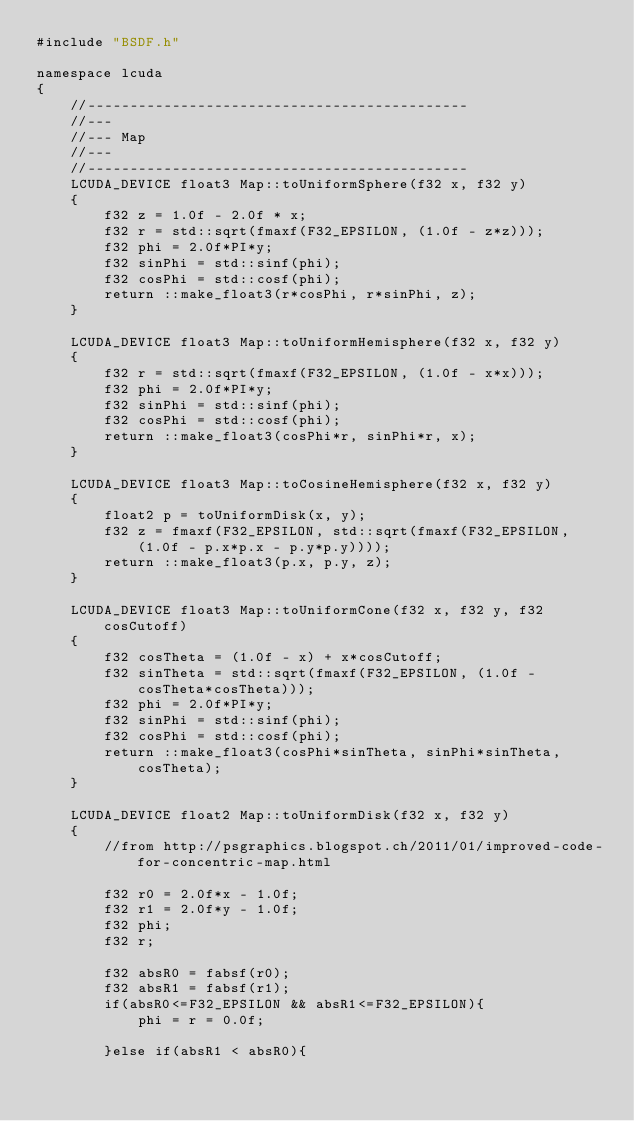Convert code to text. <code><loc_0><loc_0><loc_500><loc_500><_Cuda_>#include "BSDF.h"

namespace lcuda
{
    //---------------------------------------------
    //---
    //--- Map
    //---
    //---------------------------------------------
    LCUDA_DEVICE float3 Map::toUniformSphere(f32 x, f32 y)
    {
        f32 z = 1.0f - 2.0f * x;
        f32 r = std::sqrt(fmaxf(F32_EPSILON, (1.0f - z*z)));
        f32 phi = 2.0f*PI*y;
        f32 sinPhi = std::sinf(phi);
        f32 cosPhi = std::cosf(phi);
        return ::make_float3(r*cosPhi, r*sinPhi, z);
    }

    LCUDA_DEVICE float3 Map::toUniformHemisphere(f32 x, f32 y)
    {
        f32 r = std::sqrt(fmaxf(F32_EPSILON, (1.0f - x*x)));
        f32 phi = 2.0f*PI*y;
        f32 sinPhi = std::sinf(phi);
        f32 cosPhi = std::cosf(phi);
        return ::make_float3(cosPhi*r, sinPhi*r, x);
    }

    LCUDA_DEVICE float3 Map::toCosineHemisphere(f32 x, f32 y)
    {
        float2 p = toUniformDisk(x, y);
        f32 z = fmaxf(F32_EPSILON, std::sqrt(fmaxf(F32_EPSILON, (1.0f - p.x*p.x - p.y*p.y))));
        return ::make_float3(p.x, p.y, z);
    }

    LCUDA_DEVICE float3 Map::toUniformCone(f32 x, f32 y, f32 cosCutoff)
    {
        f32 cosTheta = (1.0f - x) + x*cosCutoff;
        f32 sinTheta = std::sqrt(fmaxf(F32_EPSILON, (1.0f - cosTheta*cosTheta)));
        f32 phi = 2.0f*PI*y;
        f32 sinPhi = std::sinf(phi);
        f32 cosPhi = std::cosf(phi);
        return ::make_float3(cosPhi*sinTheta, sinPhi*sinTheta, cosTheta);
    }

    LCUDA_DEVICE float2 Map::toUniformDisk(f32 x, f32 y)
    {
        //from http://psgraphics.blogspot.ch/2011/01/improved-code-for-concentric-map.html

        f32 r0 = 2.0f*x - 1.0f;
        f32 r1 = 2.0f*y - 1.0f;
        f32 phi;
        f32 r;

        f32 absR0 = fabsf(r0);
        f32 absR1 = fabsf(r1);
        if(absR0<=F32_EPSILON && absR1<=F32_EPSILON){
            phi = r = 0.0f;

        }else if(absR1 < absR0){</code> 